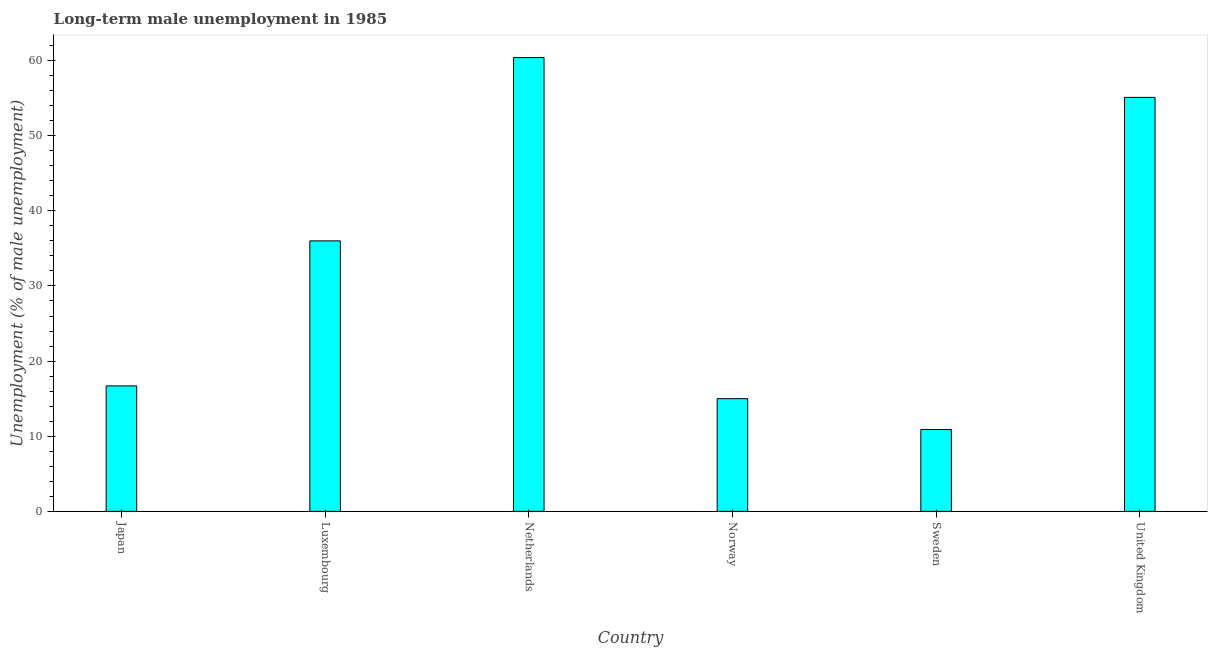Does the graph contain any zero values?
Provide a short and direct response. No. What is the title of the graph?
Offer a very short reply. Long-term male unemployment in 1985. What is the label or title of the Y-axis?
Offer a terse response. Unemployment (% of male unemployment). Across all countries, what is the maximum long-term male unemployment?
Keep it short and to the point. 60.4. Across all countries, what is the minimum long-term male unemployment?
Keep it short and to the point. 10.9. What is the sum of the long-term male unemployment?
Offer a very short reply. 194.1. What is the difference between the long-term male unemployment in Luxembourg and Netherlands?
Your response must be concise. -24.4. What is the average long-term male unemployment per country?
Give a very brief answer. 32.35. What is the median long-term male unemployment?
Your answer should be compact. 26.35. In how many countries, is the long-term male unemployment greater than 34 %?
Ensure brevity in your answer.  3. What is the ratio of the long-term male unemployment in Netherlands to that in United Kingdom?
Provide a short and direct response. 1.1. Is the difference between the long-term male unemployment in Japan and Norway greater than the difference between any two countries?
Give a very brief answer. No. What is the difference between the highest and the lowest long-term male unemployment?
Offer a terse response. 49.5. What is the difference between two consecutive major ticks on the Y-axis?
Your answer should be compact. 10. What is the Unemployment (% of male unemployment) in Japan?
Your response must be concise. 16.7. What is the Unemployment (% of male unemployment) in Luxembourg?
Your response must be concise. 36. What is the Unemployment (% of male unemployment) of Netherlands?
Offer a terse response. 60.4. What is the Unemployment (% of male unemployment) of Sweden?
Offer a terse response. 10.9. What is the Unemployment (% of male unemployment) of United Kingdom?
Offer a very short reply. 55.1. What is the difference between the Unemployment (% of male unemployment) in Japan and Luxembourg?
Ensure brevity in your answer.  -19.3. What is the difference between the Unemployment (% of male unemployment) in Japan and Netherlands?
Provide a short and direct response. -43.7. What is the difference between the Unemployment (% of male unemployment) in Japan and Norway?
Give a very brief answer. 1.7. What is the difference between the Unemployment (% of male unemployment) in Japan and Sweden?
Provide a succinct answer. 5.8. What is the difference between the Unemployment (% of male unemployment) in Japan and United Kingdom?
Offer a very short reply. -38.4. What is the difference between the Unemployment (% of male unemployment) in Luxembourg and Netherlands?
Your answer should be compact. -24.4. What is the difference between the Unemployment (% of male unemployment) in Luxembourg and Sweden?
Your answer should be compact. 25.1. What is the difference between the Unemployment (% of male unemployment) in Luxembourg and United Kingdom?
Provide a succinct answer. -19.1. What is the difference between the Unemployment (% of male unemployment) in Netherlands and Norway?
Keep it short and to the point. 45.4. What is the difference between the Unemployment (% of male unemployment) in Netherlands and Sweden?
Make the answer very short. 49.5. What is the difference between the Unemployment (% of male unemployment) in Norway and Sweden?
Give a very brief answer. 4.1. What is the difference between the Unemployment (% of male unemployment) in Norway and United Kingdom?
Offer a terse response. -40.1. What is the difference between the Unemployment (% of male unemployment) in Sweden and United Kingdom?
Your answer should be very brief. -44.2. What is the ratio of the Unemployment (% of male unemployment) in Japan to that in Luxembourg?
Offer a very short reply. 0.46. What is the ratio of the Unemployment (% of male unemployment) in Japan to that in Netherlands?
Keep it short and to the point. 0.28. What is the ratio of the Unemployment (% of male unemployment) in Japan to that in Norway?
Your response must be concise. 1.11. What is the ratio of the Unemployment (% of male unemployment) in Japan to that in Sweden?
Ensure brevity in your answer.  1.53. What is the ratio of the Unemployment (% of male unemployment) in Japan to that in United Kingdom?
Keep it short and to the point. 0.3. What is the ratio of the Unemployment (% of male unemployment) in Luxembourg to that in Netherlands?
Make the answer very short. 0.6. What is the ratio of the Unemployment (% of male unemployment) in Luxembourg to that in Sweden?
Ensure brevity in your answer.  3.3. What is the ratio of the Unemployment (% of male unemployment) in Luxembourg to that in United Kingdom?
Keep it short and to the point. 0.65. What is the ratio of the Unemployment (% of male unemployment) in Netherlands to that in Norway?
Provide a short and direct response. 4.03. What is the ratio of the Unemployment (% of male unemployment) in Netherlands to that in Sweden?
Offer a very short reply. 5.54. What is the ratio of the Unemployment (% of male unemployment) in Netherlands to that in United Kingdom?
Make the answer very short. 1.1. What is the ratio of the Unemployment (% of male unemployment) in Norway to that in Sweden?
Your answer should be very brief. 1.38. What is the ratio of the Unemployment (% of male unemployment) in Norway to that in United Kingdom?
Make the answer very short. 0.27. What is the ratio of the Unemployment (% of male unemployment) in Sweden to that in United Kingdom?
Offer a terse response. 0.2. 